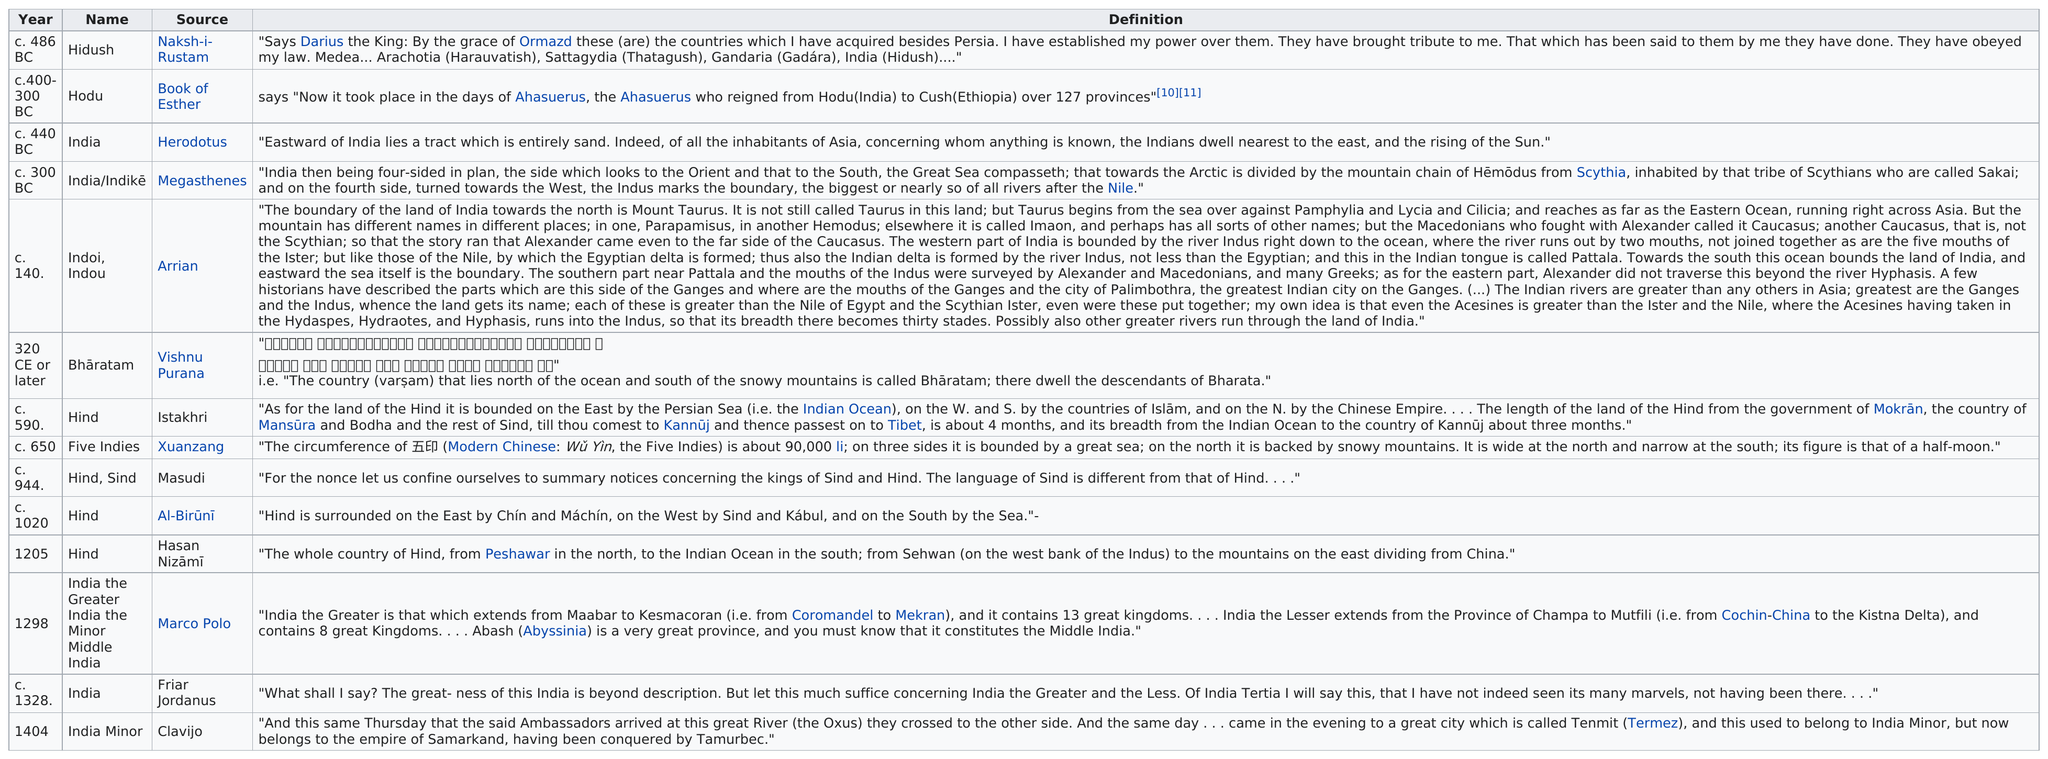Point out several critical features in this image. The most recent source for the name Clavijo is... The nation's name before the book of Esther was called 'Hodu,' and it was also referred to as 'Hidush.' 